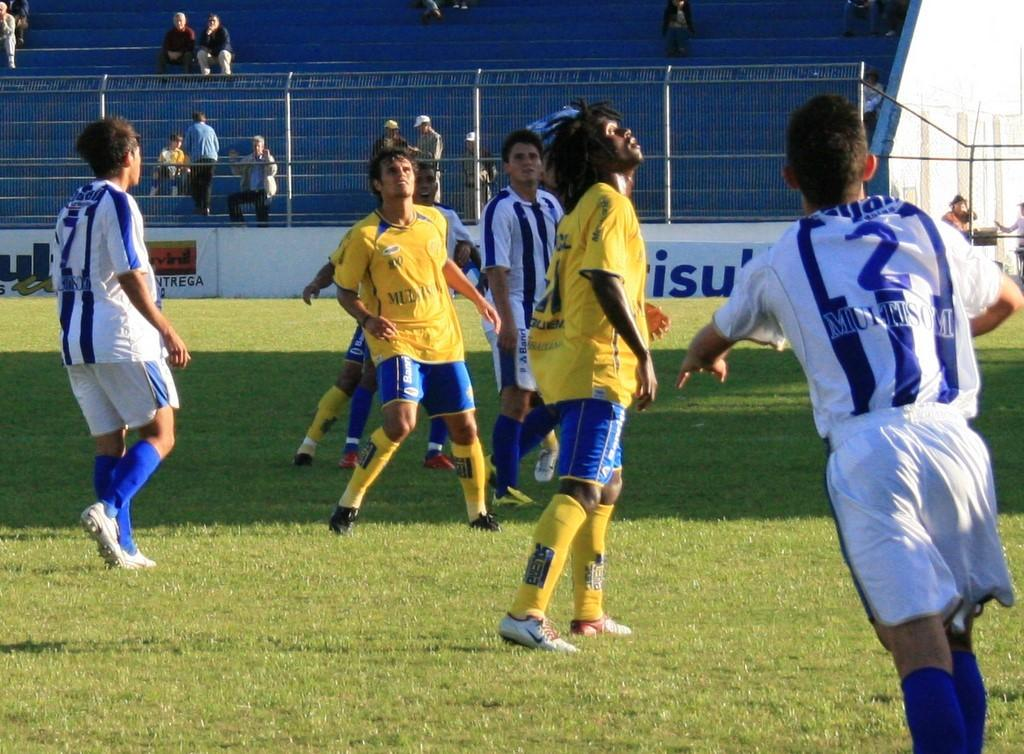<image>
Provide a brief description of the given image. Several soccer players are on a field. One player's jersey number is 2. 